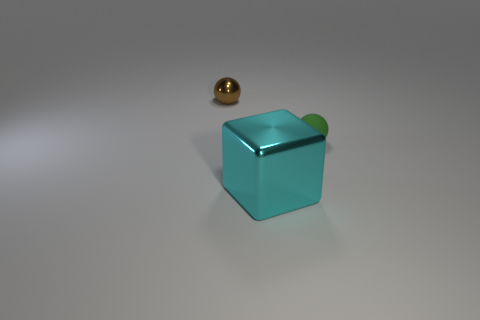Are there any other things that have the same material as the green object?
Offer a terse response. No. There is a metal object that is on the right side of the object left of the metallic object that is in front of the tiny brown thing; what is its size?
Give a very brief answer. Large. What is the shape of the tiny green object?
Ensure brevity in your answer.  Sphere. What number of shiny objects are left of the metal thing behind the tiny green sphere?
Give a very brief answer. 0. What number of other things are made of the same material as the tiny green sphere?
Your response must be concise. 0. Is the material of the small object that is to the right of the big cyan cube the same as the large cyan thing that is in front of the tiny metallic thing?
Ensure brevity in your answer.  No. Is there any other thing that has the same shape as the tiny rubber thing?
Offer a terse response. Yes. Is the material of the large thing the same as the tiny sphere on the left side of the tiny green ball?
Provide a succinct answer. Yes. What color is the small thing right of the shiny thing in front of the tiny object that is on the left side of the green thing?
Your answer should be compact. Green. What is the shape of the rubber thing that is the same size as the brown shiny thing?
Make the answer very short. Sphere. 